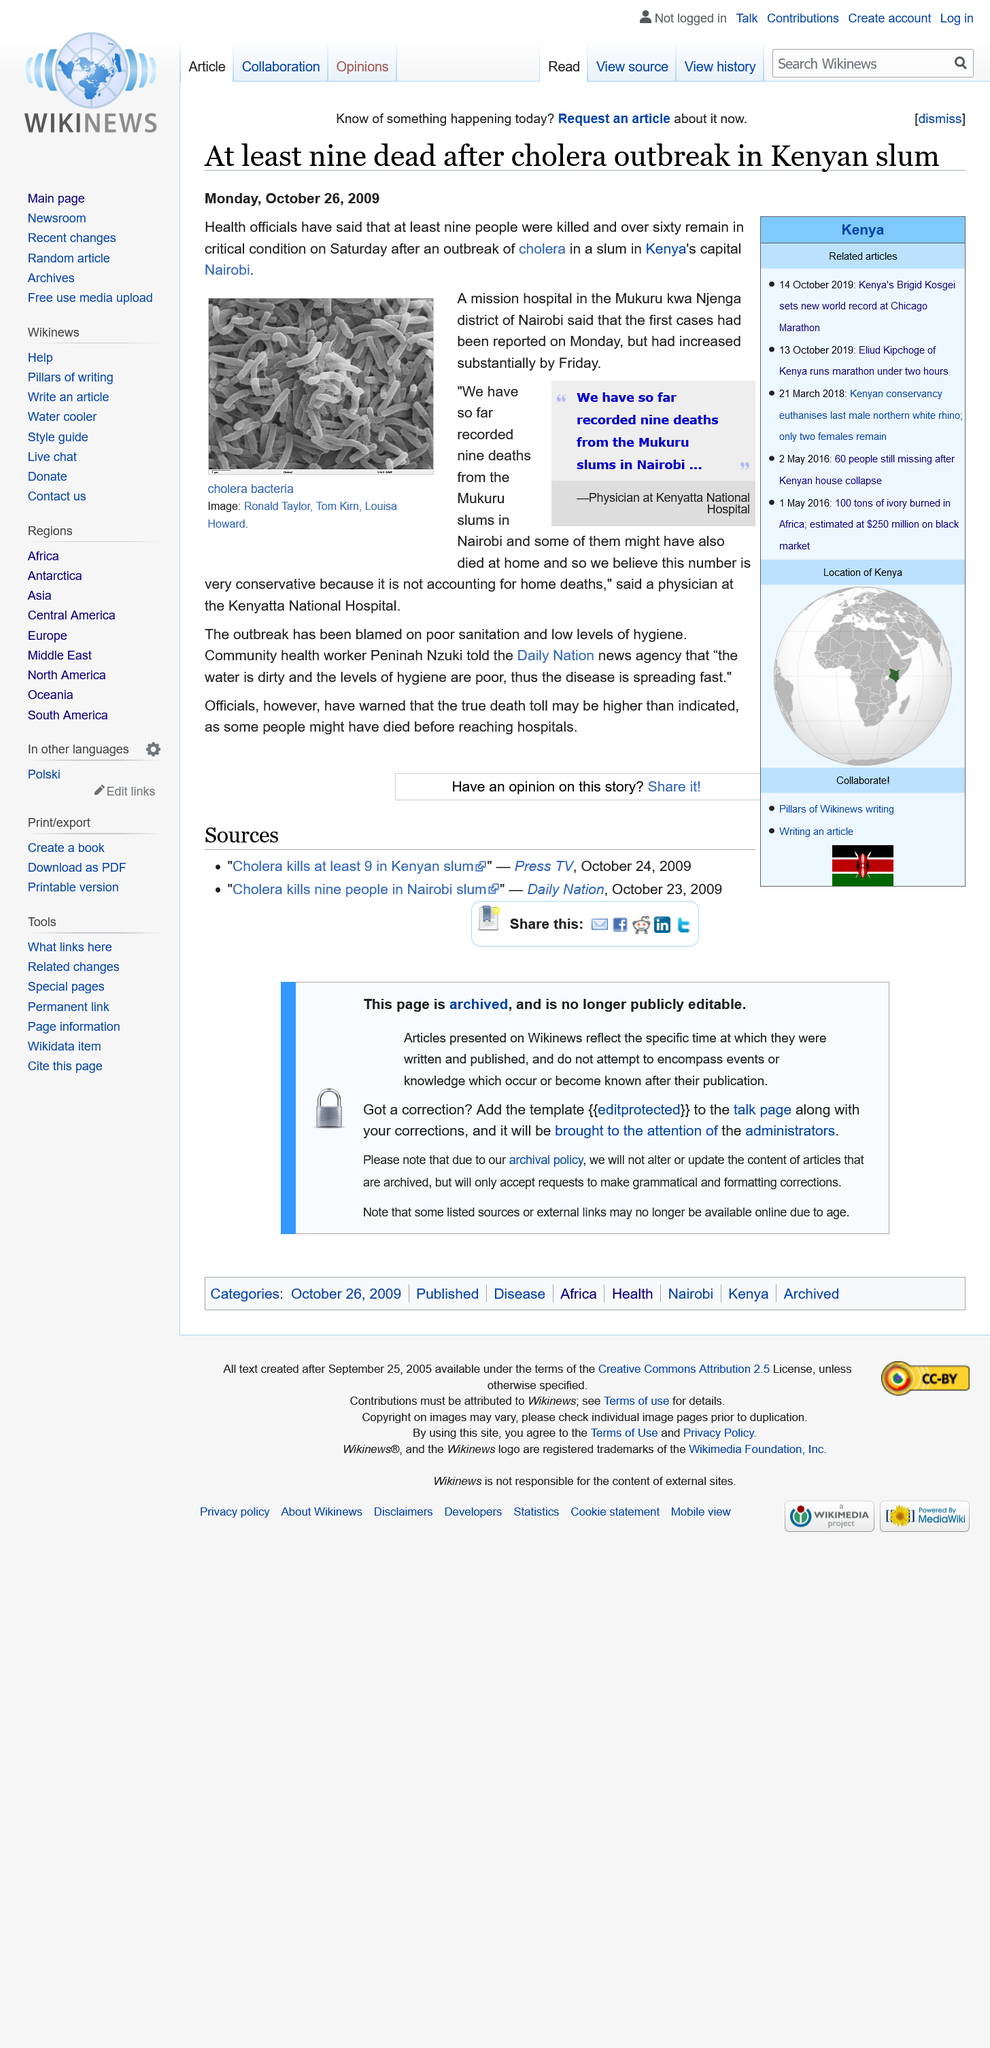Outline some significant characteristics in this image. The recorded number of deaths from the Mukur slums in Nairobi is believed to be inaccurate by a physician at Kenyatta National hospital due to the exclusion of home deaths. Nine individuals have perished as a result of a cholera outbreak in a Kenyan slum, according to recent reports. Sixty or more individuals are currently in critical condition. 